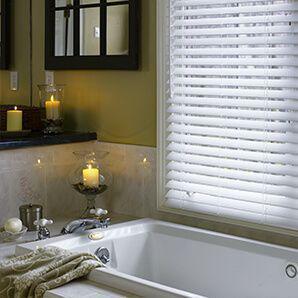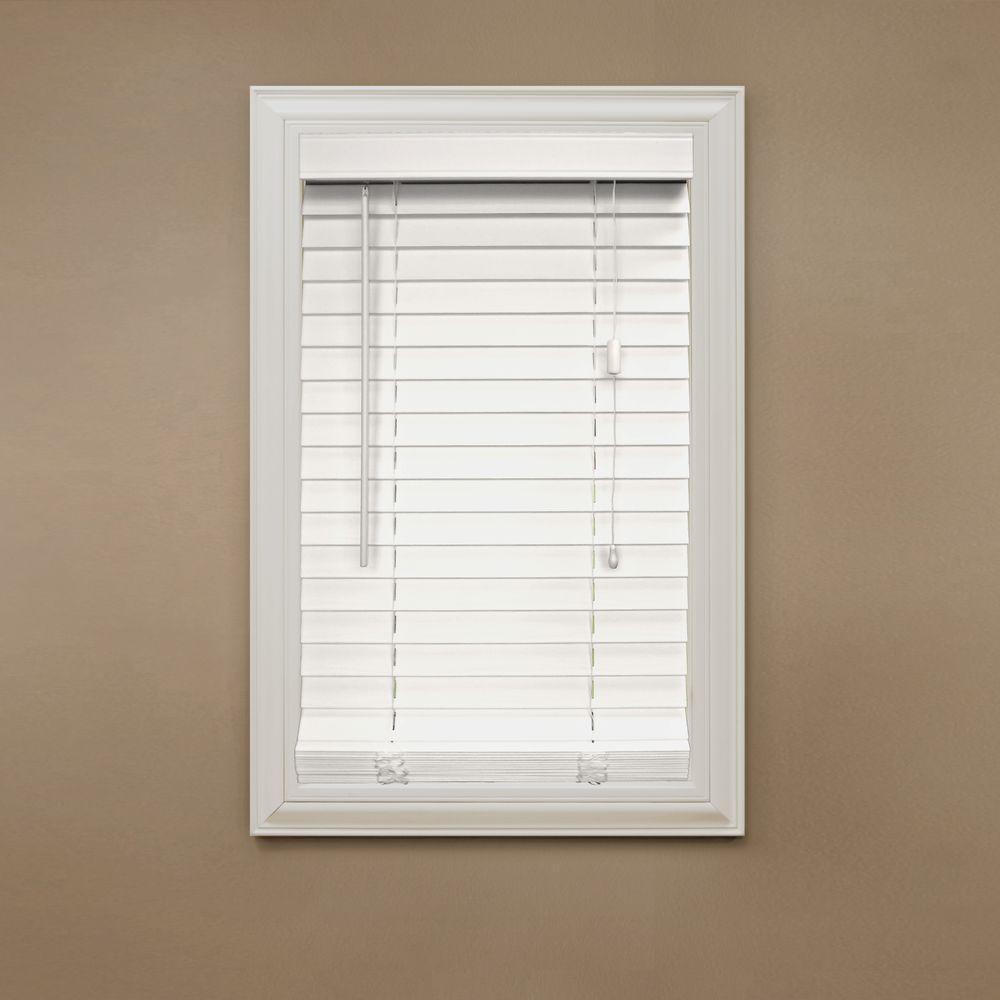The first image is the image on the left, the second image is the image on the right. Examine the images to the left and right. Is the description "There are two blinds." accurate? Answer yes or no. Yes. The first image is the image on the left, the second image is the image on the right. Given the left and right images, does the statement "The blinds in a room above a bathtub let in the light in the image on the left." hold true? Answer yes or no. Yes. 